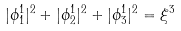<formula> <loc_0><loc_0><loc_500><loc_500>| \phi ^ { 1 } _ { 1 } | ^ { 2 } + | \phi ^ { 1 } _ { 2 } | ^ { 2 } + | \phi ^ { 1 } _ { 3 } | ^ { 2 } = \xi ^ { 3 }</formula> 